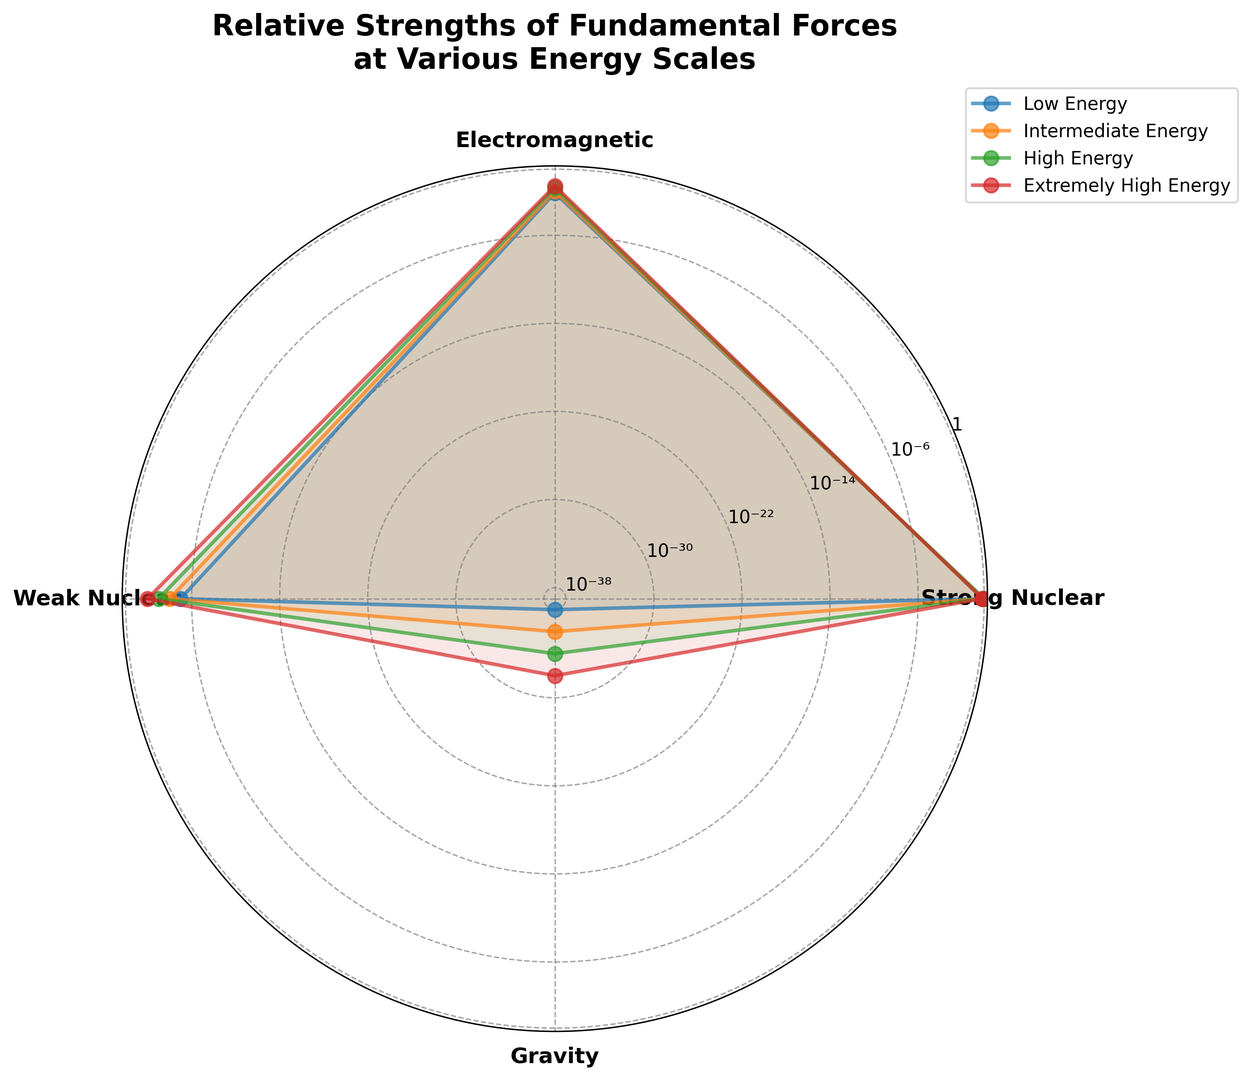Which force has the highest strength at low energy scales? At low energy scales, the force with the highest strength is represented by the point farthest from the origin on the radar chart at low energy. This point is associated with the "Strong Nuclear" force.
Answer: Strong Nuclear How does the relative strength of the Electromagnetic force change from low energy to extremely high energy? Observation of the Electromagnetic force line from low energy (0.007) to extremely high energy (0.03) shows a gradual increase in the distance from the origin, indicating that its relative strength increases.
Answer: It increases Which force has the lowest strength at intermediate energy scales? At intermediate energy scales, the force with the point closest to the origin represents the lowest strength. This point corresponds to "Gravity" (1e-36).
Answer: Gravity By what factor does the strength of the Weak Nuclear force increase from low energy to extremely high energy? The strength at low energy is 0.00001 and at extremely high energy is 0.01. The factor of increase is calculated as 0.01 / 0.00001.
Answer: 1000 How do the relative strengths of the Strong Nuclear and Electromagnetic forces compare at high energy? At high energy, compare the positions of the Strong Nuclear (0.8) and Electromagnetic (0.02) data points. The Strong Nuclear force has a higher strength than the Electromagnetic force.
Answer: Strong Nuclear is higher Which force shows the least change in relative strength across all energy scales? By observing the length of the lines and comparing the deviation from each energy level, the Strong Nuclear force shows the least change, gradually decreasing from 1.0 to 0.7.
Answer: Strong Nuclear What is the order of the forces based on their strengths at extremely high energy scales, from highest to lowest? At extremely high energy, the points farthest from the origin denote higher strengths. Ordered from highest to lowest: Strong Nuclear (0.7), Electromagnetic (0.03), Weak Nuclear (0.01), Gravity (1e-32).
Answer: Strong Nuclear, Electromagnetic, Weak Nuclear, Gravity Calculate the average strength of the Electromagnetic force across all energy scales. The values are 0.007, 0.01, 0.02, and 0.03. Summing these gives 0.067, and the average is 0.067 / 4.
Answer: 0.01675 What trend is observed in the relative strength of Gravity from low to extremely high energy scales? The Gravity force's strengths at these levels (1e-38, 1e-36, 1e-34, 1e-32) increase as the energy scale increases, showing a consistent rising trend in the position from the origin.
Answer: Increasing 